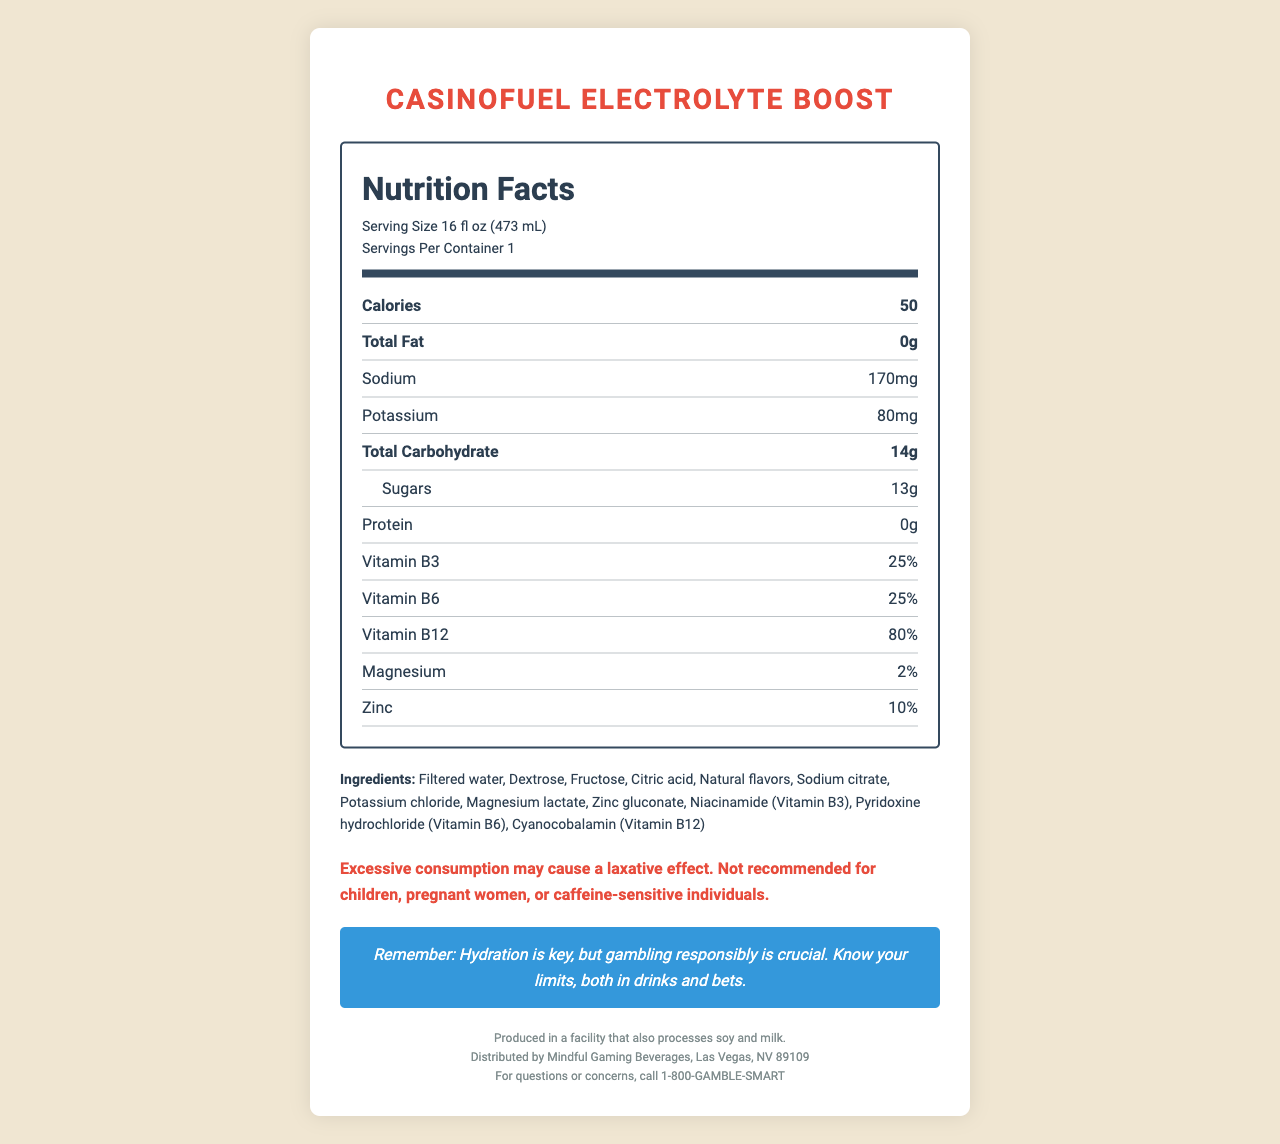what is the product name? The product name is prominently displayed at the top as "CasinoFuel Electrolyte Boost."
Answer: CasinoFuel Electrolyte Boost how many calories are in a serving? According to the nutrition facts, one serving size (16 fl oz) contains 50 calories.
Answer: 50 what is the serving size of CasinoFuel Electrolyte Boost? The serving size information is given as "16 fl oz (473 mL)" in the nutrition label.
Answer: 16 fl oz (473 mL) how much sodium does one serving contain? The nutrition label indicates that one serving contains 170 mg of sodium.
Answer: 170 mg what warning is given for consuming this product? The warning section under the nutrition label specifies this caution.
Answer: Excessive consumption may cause a laxative effect. Not recommended for children, pregnant women, or caffeine-sensitive individuals. how many servings are in one container? The label shows "Servings Per Container: 1."
Answer: 1 what vitamins are included in the CasinoFuel Electrolyte Boost? The nutrition label lists Vitamin B3, Vitamin B6, and Vitamin B12.
Answer: Vitamin B3, Vitamin B6, Vitamin B12 how much sugar is in one serving? The nutrition label specifies that there are 13 g of sugars in one serving.
Answer: 13 g which vitamin is present in the highest percentage? A. Vitamin B3 B. Vitamin B6 C. Vitamin B12 D. Magnesium The nutrition label shows Vitamin B12 at 80%, which is the highest among the listed vitamins and minerals.
Answer: C. Vitamin B12 what are the main electrolytes found in this drink? A. Sodium and Calcium B. Potassium and Magnesium C. Sodium and Potassium D. Magnesium and Zinc The nutrition label lists sodium (170 mg) and potassium (80 mg) as the primary electrolytes.
Answer: C. Sodium and Potassium does this product contain any protein? The nutrition label indicates 0 g protein per serving.
Answer: No is the product suitable for children and pregnant women? The warning clearly states that it is not recommended for children or pregnant women.
Answer: No summarize the primary purpose and content of this document. The document aims to inform consumers, particularly casino athletes, about the nutritional benefits and considerations for consuming the sports drink "CasinoFuel Electrolyte Boost." It encompasses all necessary details from nutritional values to specific warnings and company information.
Answer: The document provides a detailed nutrition facts label for the CasinoFuel Electrolyte Boost, a sports drink. It outlines serving size, calories, and nutritional content including sodium, potassium, carbohydrates, and various B-vitamins. Warnings and responsible gaming messages are also included, along with the company's contact information and allergen notes. how many grams of total carbohydrate are there? The nutrition label shows a total carbohydrate content of 14 g per serving.
Answer: 14 g who distributes this product? The footer of the document states that it is distributed by "Mindful Gaming Beverages, Las Vegas, NV 89109."
Answer: Mindful Gaming Beverages, Las Vegas, NV 89109 how can I contact the company for questions or concerns? The contact information at the bottom of the document advises calling 1-800-GAMBLE-SMART for any questions or concerns.
Answer: Call 1-800-GAMBLE-SMART what is the total amount of vitamins and minerals in one serving? The document lists individual percentages for vitamins B3, B6, B12, magnesium, and zinc but doesn't provide enough information to sum up a total amount comprehensively.
Answer: Cannot be determined 